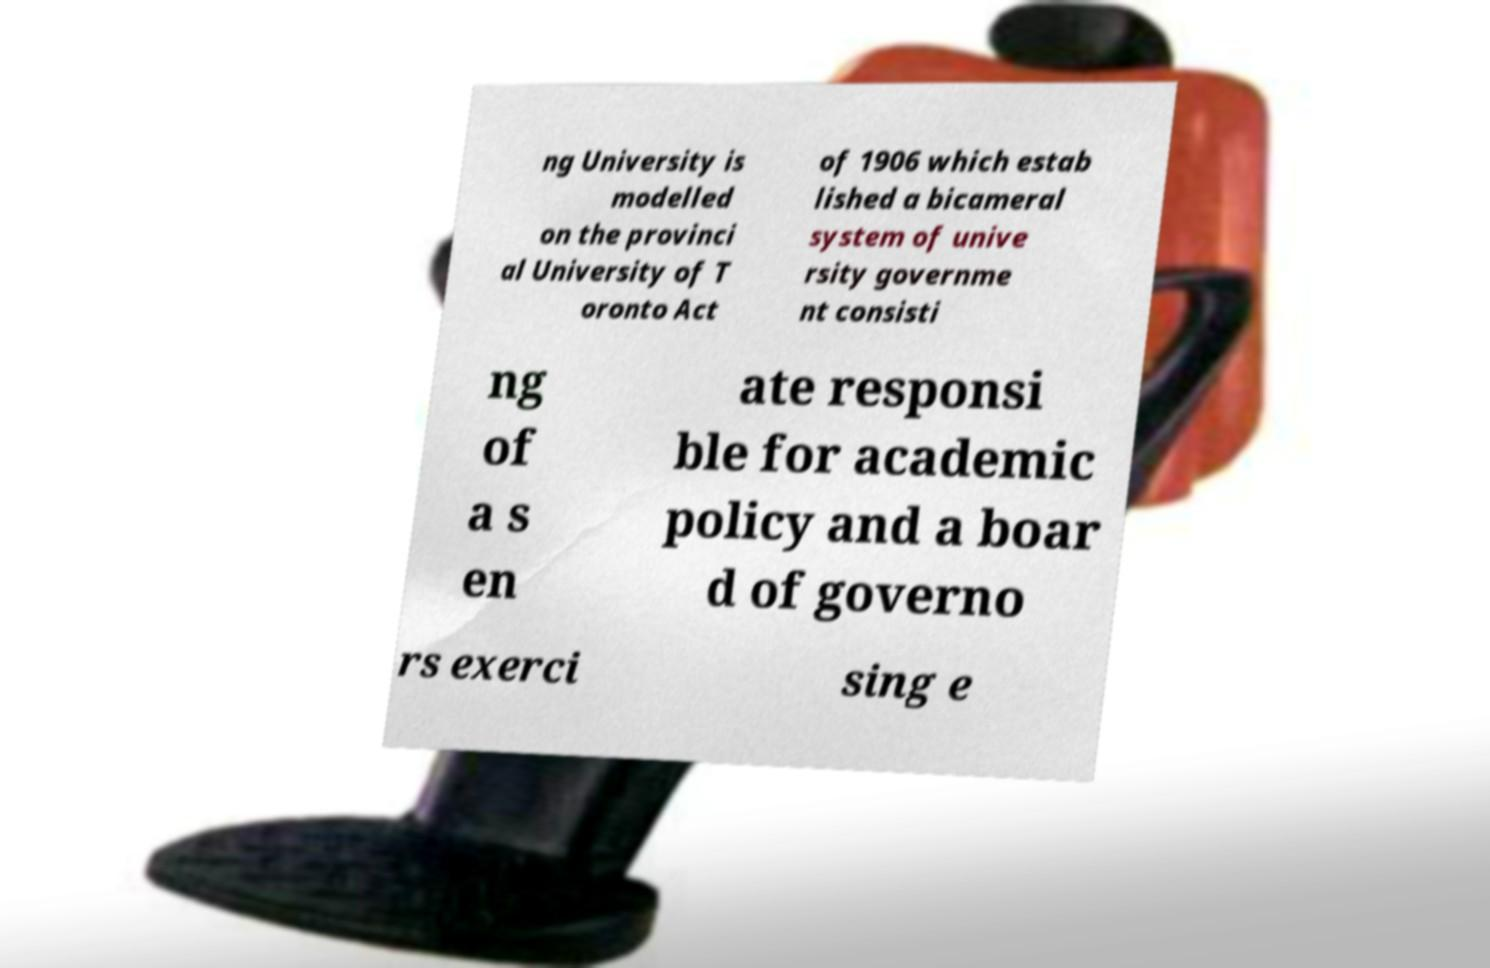Please identify and transcribe the text found in this image. ng University is modelled on the provinci al University of T oronto Act of 1906 which estab lished a bicameral system of unive rsity governme nt consisti ng of a s en ate responsi ble for academic policy and a boar d of governo rs exerci sing e 